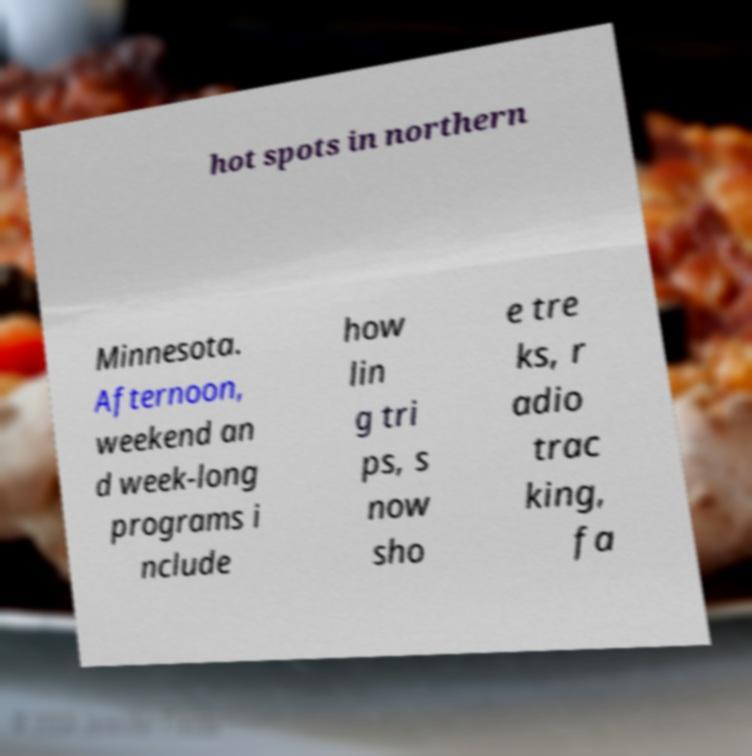Could you assist in decoding the text presented in this image and type it out clearly? hot spots in northern Minnesota. Afternoon, weekend an d week-long programs i nclude how lin g tri ps, s now sho e tre ks, r adio trac king, fa 